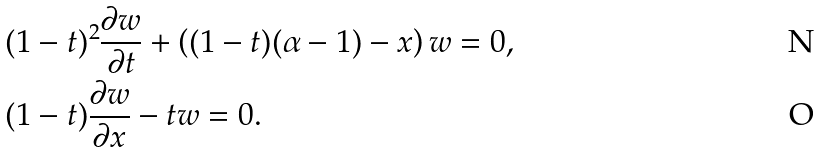<formula> <loc_0><loc_0><loc_500><loc_500>& ( 1 - t ) ^ { 2 } \frac { \partial w } { \partial t } + \left ( ( 1 - t ) ( \alpha - 1 ) - x \right ) w = 0 , \\ & ( 1 - t ) \frac { \partial w } { \partial x } - t w = 0 .</formula> 